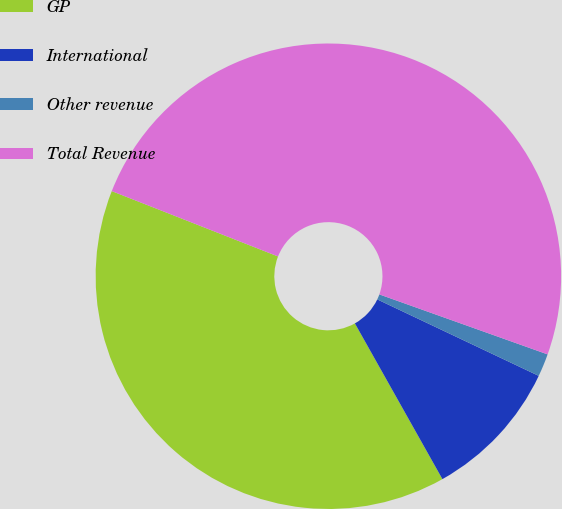Convert chart. <chart><loc_0><loc_0><loc_500><loc_500><pie_chart><fcel>GP<fcel>International<fcel>Other revenue<fcel>Total Revenue<nl><fcel>39.11%<fcel>9.81%<fcel>1.59%<fcel>49.49%<nl></chart> 